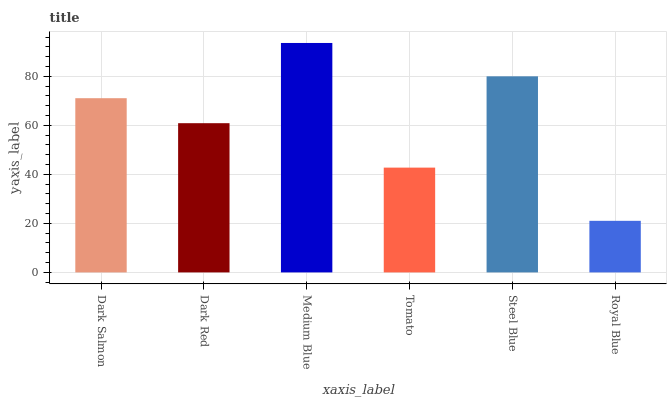Is Royal Blue the minimum?
Answer yes or no. Yes. Is Medium Blue the maximum?
Answer yes or no. Yes. Is Dark Red the minimum?
Answer yes or no. No. Is Dark Red the maximum?
Answer yes or no. No. Is Dark Salmon greater than Dark Red?
Answer yes or no. Yes. Is Dark Red less than Dark Salmon?
Answer yes or no. Yes. Is Dark Red greater than Dark Salmon?
Answer yes or no. No. Is Dark Salmon less than Dark Red?
Answer yes or no. No. Is Dark Salmon the high median?
Answer yes or no. Yes. Is Dark Red the low median?
Answer yes or no. Yes. Is Tomato the high median?
Answer yes or no. No. Is Dark Salmon the low median?
Answer yes or no. No. 